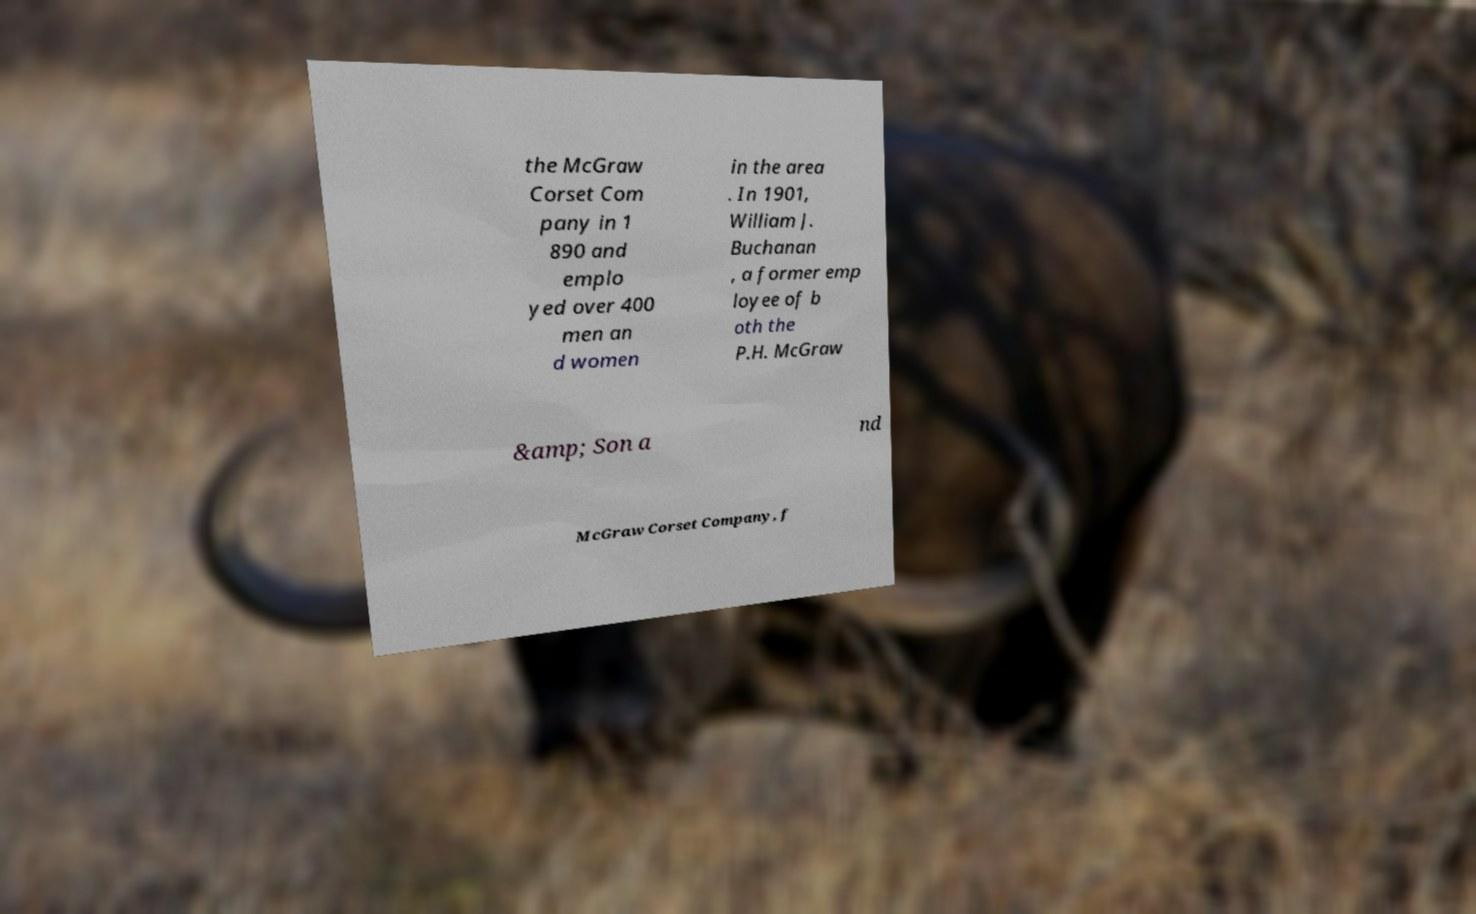For documentation purposes, I need the text within this image transcribed. Could you provide that? the McGraw Corset Com pany in 1 890 and emplo yed over 400 men an d women in the area . In 1901, William J. Buchanan , a former emp loyee of b oth the P.H. McGraw &amp; Son a nd McGraw Corset Company, f 